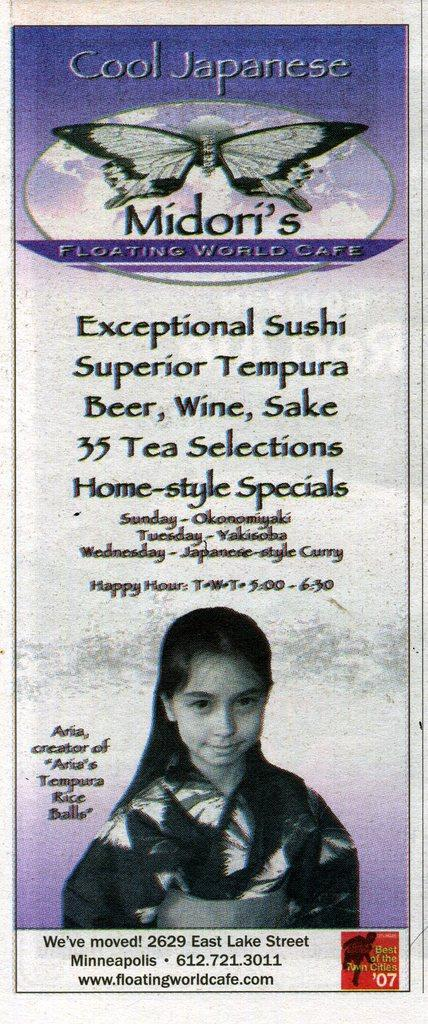What is present in the image that contains both images and text? There is a poster in the image that contains images and text. How many letters are visible on the poster in the image? There is no specific number of letters mentioned in the facts, so we cannot definitively answer this question. However, we can say that the poster contains text. Can you see a bite taken out of the poster in the image? No, there is no mention of a bite or any damage to the poster in the provided facts. 